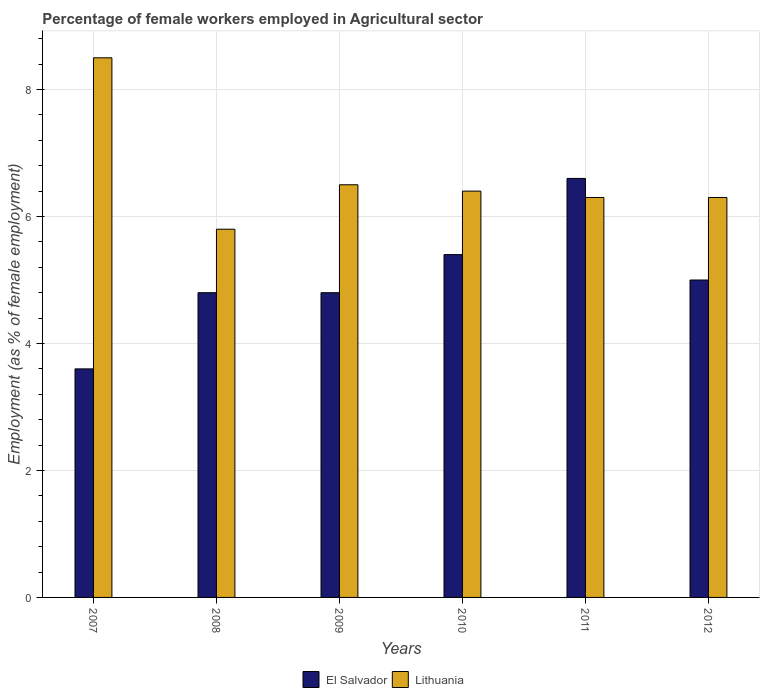How many groups of bars are there?
Your response must be concise. 6. How many bars are there on the 2nd tick from the left?
Offer a very short reply. 2. How many bars are there on the 5th tick from the right?
Provide a succinct answer. 2. In how many cases, is the number of bars for a given year not equal to the number of legend labels?
Make the answer very short. 0. What is the percentage of females employed in Agricultural sector in El Salvador in 2009?
Ensure brevity in your answer.  4.8. Across all years, what is the maximum percentage of females employed in Agricultural sector in El Salvador?
Provide a short and direct response. 6.6. Across all years, what is the minimum percentage of females employed in Agricultural sector in Lithuania?
Your answer should be very brief. 5.8. What is the total percentage of females employed in Agricultural sector in Lithuania in the graph?
Make the answer very short. 39.8. What is the difference between the percentage of females employed in Agricultural sector in Lithuania in 2009 and that in 2010?
Ensure brevity in your answer.  0.1. What is the difference between the percentage of females employed in Agricultural sector in Lithuania in 2011 and the percentage of females employed in Agricultural sector in El Salvador in 2010?
Your answer should be compact. 0.9. What is the average percentage of females employed in Agricultural sector in El Salvador per year?
Offer a terse response. 5.03. What is the ratio of the percentage of females employed in Agricultural sector in El Salvador in 2009 to that in 2012?
Provide a short and direct response. 0.96. Is the percentage of females employed in Agricultural sector in Lithuania in 2007 less than that in 2008?
Give a very brief answer. No. What is the difference between the highest and the second highest percentage of females employed in Agricultural sector in Lithuania?
Provide a succinct answer. 2. What is the difference between the highest and the lowest percentage of females employed in Agricultural sector in El Salvador?
Provide a succinct answer. 3. In how many years, is the percentage of females employed in Agricultural sector in Lithuania greater than the average percentage of females employed in Agricultural sector in Lithuania taken over all years?
Your answer should be very brief. 1. Is the sum of the percentage of females employed in Agricultural sector in El Salvador in 2008 and 2012 greater than the maximum percentage of females employed in Agricultural sector in Lithuania across all years?
Ensure brevity in your answer.  Yes. What does the 2nd bar from the left in 2011 represents?
Your answer should be very brief. Lithuania. What does the 1st bar from the right in 2009 represents?
Provide a short and direct response. Lithuania. How many years are there in the graph?
Your answer should be compact. 6. Are the values on the major ticks of Y-axis written in scientific E-notation?
Offer a very short reply. No. Does the graph contain any zero values?
Offer a terse response. No. Does the graph contain grids?
Your answer should be compact. Yes. Where does the legend appear in the graph?
Make the answer very short. Bottom center. How are the legend labels stacked?
Give a very brief answer. Horizontal. What is the title of the graph?
Give a very brief answer. Percentage of female workers employed in Agricultural sector. What is the label or title of the X-axis?
Provide a succinct answer. Years. What is the label or title of the Y-axis?
Offer a very short reply. Employment (as % of female employment). What is the Employment (as % of female employment) of El Salvador in 2007?
Offer a very short reply. 3.6. What is the Employment (as % of female employment) of Lithuania in 2007?
Your response must be concise. 8.5. What is the Employment (as % of female employment) in El Salvador in 2008?
Make the answer very short. 4.8. What is the Employment (as % of female employment) of Lithuania in 2008?
Provide a short and direct response. 5.8. What is the Employment (as % of female employment) of El Salvador in 2009?
Ensure brevity in your answer.  4.8. What is the Employment (as % of female employment) in Lithuania in 2009?
Provide a short and direct response. 6.5. What is the Employment (as % of female employment) in El Salvador in 2010?
Ensure brevity in your answer.  5.4. What is the Employment (as % of female employment) of Lithuania in 2010?
Your response must be concise. 6.4. What is the Employment (as % of female employment) of El Salvador in 2011?
Make the answer very short. 6.6. What is the Employment (as % of female employment) in Lithuania in 2011?
Your answer should be compact. 6.3. What is the Employment (as % of female employment) in Lithuania in 2012?
Give a very brief answer. 6.3. Across all years, what is the maximum Employment (as % of female employment) in El Salvador?
Your answer should be compact. 6.6. Across all years, what is the maximum Employment (as % of female employment) of Lithuania?
Ensure brevity in your answer.  8.5. Across all years, what is the minimum Employment (as % of female employment) of El Salvador?
Give a very brief answer. 3.6. Across all years, what is the minimum Employment (as % of female employment) in Lithuania?
Offer a terse response. 5.8. What is the total Employment (as % of female employment) of El Salvador in the graph?
Make the answer very short. 30.2. What is the total Employment (as % of female employment) in Lithuania in the graph?
Keep it short and to the point. 39.8. What is the difference between the Employment (as % of female employment) of El Salvador in 2007 and that in 2009?
Offer a terse response. -1.2. What is the difference between the Employment (as % of female employment) in El Salvador in 2007 and that in 2010?
Your answer should be compact. -1.8. What is the difference between the Employment (as % of female employment) of Lithuania in 2008 and that in 2009?
Ensure brevity in your answer.  -0.7. What is the difference between the Employment (as % of female employment) of El Salvador in 2008 and that in 2011?
Offer a terse response. -1.8. What is the difference between the Employment (as % of female employment) of Lithuania in 2008 and that in 2011?
Give a very brief answer. -0.5. What is the difference between the Employment (as % of female employment) of Lithuania in 2008 and that in 2012?
Your answer should be very brief. -0.5. What is the difference between the Employment (as % of female employment) of El Salvador in 2009 and that in 2010?
Provide a short and direct response. -0.6. What is the difference between the Employment (as % of female employment) of Lithuania in 2009 and that in 2010?
Provide a succinct answer. 0.1. What is the difference between the Employment (as % of female employment) of Lithuania in 2009 and that in 2011?
Provide a short and direct response. 0.2. What is the difference between the Employment (as % of female employment) of El Salvador in 2010 and that in 2011?
Your answer should be compact. -1.2. What is the difference between the Employment (as % of female employment) of Lithuania in 2011 and that in 2012?
Your response must be concise. 0. What is the difference between the Employment (as % of female employment) of El Salvador in 2007 and the Employment (as % of female employment) of Lithuania in 2009?
Give a very brief answer. -2.9. What is the difference between the Employment (as % of female employment) in El Salvador in 2007 and the Employment (as % of female employment) in Lithuania in 2010?
Make the answer very short. -2.8. What is the difference between the Employment (as % of female employment) in El Salvador in 2007 and the Employment (as % of female employment) in Lithuania in 2012?
Offer a very short reply. -2.7. What is the difference between the Employment (as % of female employment) in El Salvador in 2008 and the Employment (as % of female employment) in Lithuania in 2011?
Give a very brief answer. -1.5. What is the difference between the Employment (as % of female employment) of El Salvador in 2009 and the Employment (as % of female employment) of Lithuania in 2011?
Provide a short and direct response. -1.5. What is the difference between the Employment (as % of female employment) of El Salvador in 2010 and the Employment (as % of female employment) of Lithuania in 2011?
Make the answer very short. -0.9. What is the average Employment (as % of female employment) in El Salvador per year?
Give a very brief answer. 5.03. What is the average Employment (as % of female employment) in Lithuania per year?
Ensure brevity in your answer.  6.63. In the year 2009, what is the difference between the Employment (as % of female employment) of El Salvador and Employment (as % of female employment) of Lithuania?
Offer a terse response. -1.7. In the year 2010, what is the difference between the Employment (as % of female employment) in El Salvador and Employment (as % of female employment) in Lithuania?
Give a very brief answer. -1. In the year 2011, what is the difference between the Employment (as % of female employment) in El Salvador and Employment (as % of female employment) in Lithuania?
Keep it short and to the point. 0.3. What is the ratio of the Employment (as % of female employment) in Lithuania in 2007 to that in 2008?
Offer a terse response. 1.47. What is the ratio of the Employment (as % of female employment) of Lithuania in 2007 to that in 2009?
Your answer should be compact. 1.31. What is the ratio of the Employment (as % of female employment) of El Salvador in 2007 to that in 2010?
Provide a short and direct response. 0.67. What is the ratio of the Employment (as % of female employment) in Lithuania in 2007 to that in 2010?
Make the answer very short. 1.33. What is the ratio of the Employment (as % of female employment) of El Salvador in 2007 to that in 2011?
Give a very brief answer. 0.55. What is the ratio of the Employment (as % of female employment) of Lithuania in 2007 to that in 2011?
Make the answer very short. 1.35. What is the ratio of the Employment (as % of female employment) in El Salvador in 2007 to that in 2012?
Offer a terse response. 0.72. What is the ratio of the Employment (as % of female employment) of Lithuania in 2007 to that in 2012?
Provide a succinct answer. 1.35. What is the ratio of the Employment (as % of female employment) in Lithuania in 2008 to that in 2009?
Provide a succinct answer. 0.89. What is the ratio of the Employment (as % of female employment) in El Salvador in 2008 to that in 2010?
Your answer should be very brief. 0.89. What is the ratio of the Employment (as % of female employment) of Lithuania in 2008 to that in 2010?
Ensure brevity in your answer.  0.91. What is the ratio of the Employment (as % of female employment) in El Salvador in 2008 to that in 2011?
Make the answer very short. 0.73. What is the ratio of the Employment (as % of female employment) in Lithuania in 2008 to that in 2011?
Give a very brief answer. 0.92. What is the ratio of the Employment (as % of female employment) of El Salvador in 2008 to that in 2012?
Your answer should be compact. 0.96. What is the ratio of the Employment (as % of female employment) of Lithuania in 2008 to that in 2012?
Make the answer very short. 0.92. What is the ratio of the Employment (as % of female employment) of Lithuania in 2009 to that in 2010?
Provide a short and direct response. 1.02. What is the ratio of the Employment (as % of female employment) of El Salvador in 2009 to that in 2011?
Your answer should be compact. 0.73. What is the ratio of the Employment (as % of female employment) of Lithuania in 2009 to that in 2011?
Your answer should be compact. 1.03. What is the ratio of the Employment (as % of female employment) of El Salvador in 2009 to that in 2012?
Offer a terse response. 0.96. What is the ratio of the Employment (as % of female employment) of Lithuania in 2009 to that in 2012?
Ensure brevity in your answer.  1.03. What is the ratio of the Employment (as % of female employment) of El Salvador in 2010 to that in 2011?
Provide a short and direct response. 0.82. What is the ratio of the Employment (as % of female employment) of Lithuania in 2010 to that in 2011?
Give a very brief answer. 1.02. What is the ratio of the Employment (as % of female employment) of El Salvador in 2010 to that in 2012?
Offer a very short reply. 1.08. What is the ratio of the Employment (as % of female employment) in Lithuania in 2010 to that in 2012?
Give a very brief answer. 1.02. What is the ratio of the Employment (as % of female employment) in El Salvador in 2011 to that in 2012?
Offer a terse response. 1.32. What is the difference between the highest and the lowest Employment (as % of female employment) in Lithuania?
Provide a succinct answer. 2.7. 